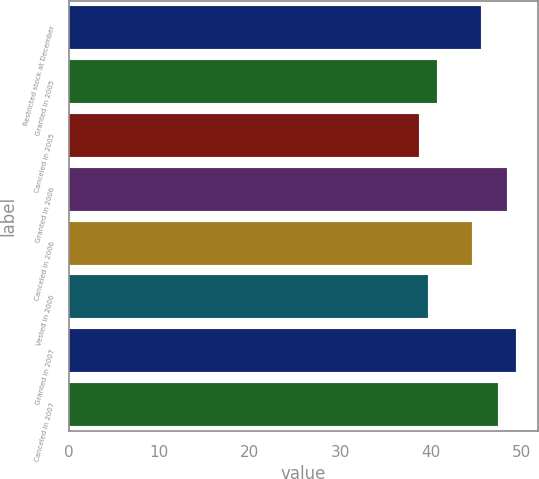<chart> <loc_0><loc_0><loc_500><loc_500><bar_chart><fcel>Restricted stock at December<fcel>Granted in 2005<fcel>Canceled in 2005<fcel>Granted in 2006<fcel>Canceled in 2006<fcel>Vested in 2006<fcel>Granted in 2007<fcel>Canceled in 2007<nl><fcel>45.54<fcel>40.69<fcel>38.75<fcel>48.45<fcel>44.57<fcel>39.72<fcel>49.42<fcel>47.48<nl></chart> 